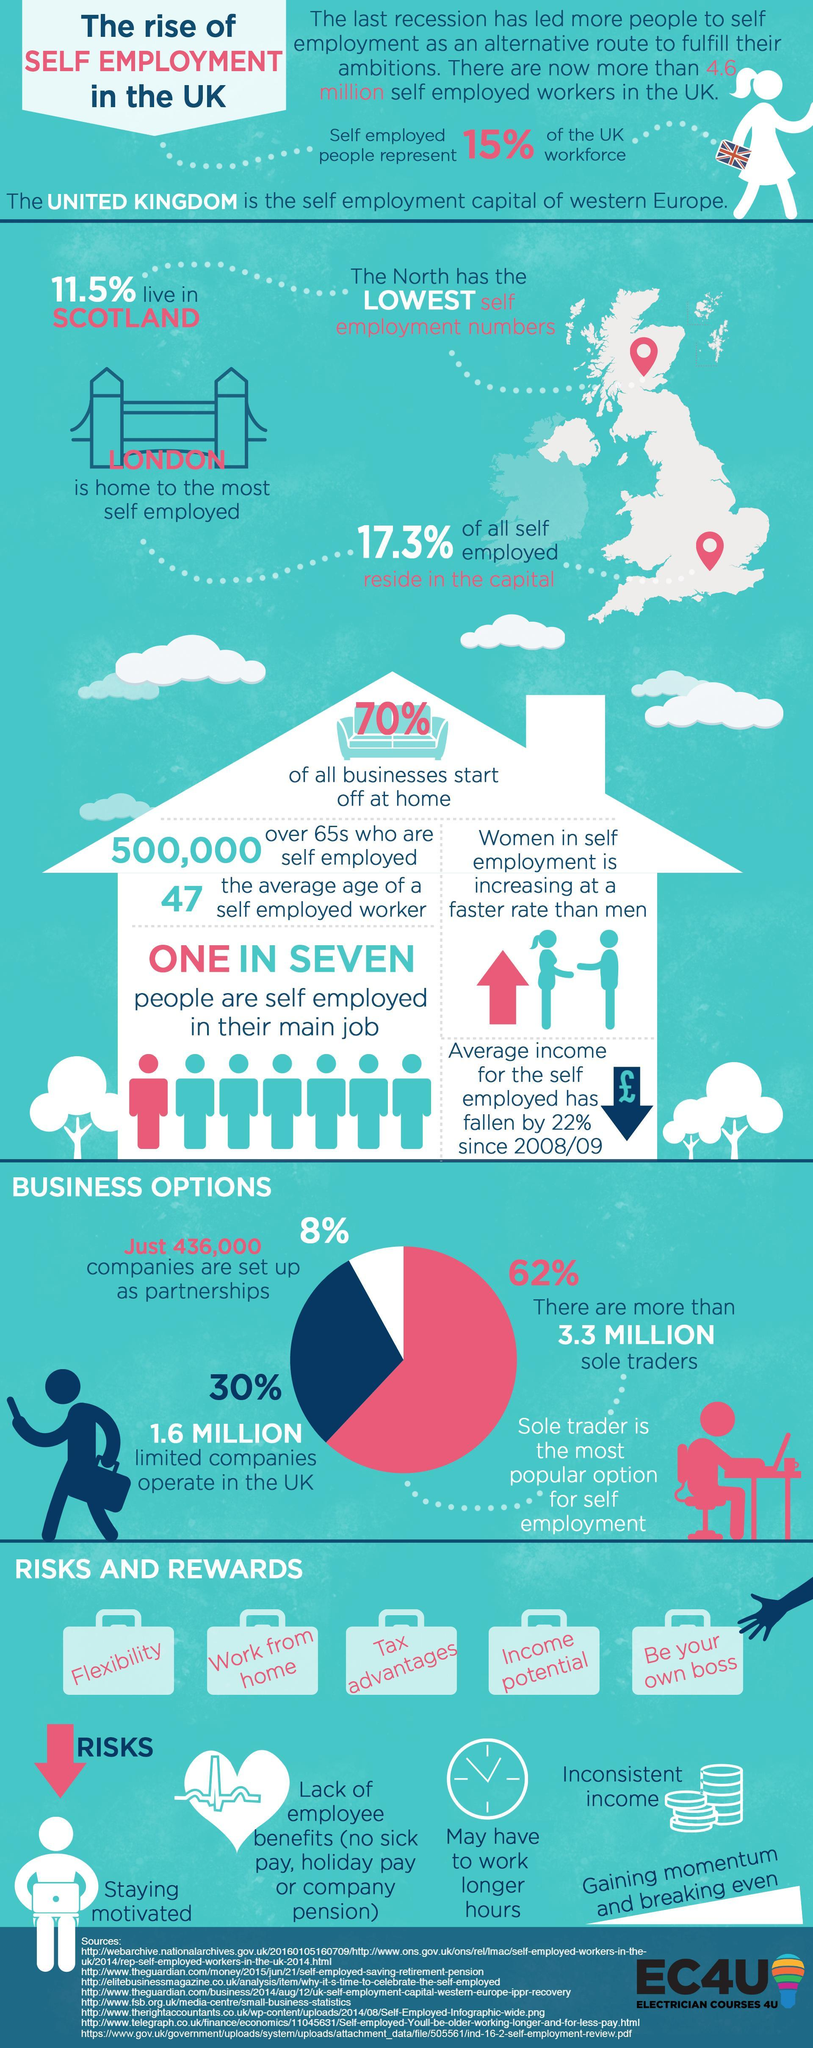Which are the three business options for the self employed?
Answer the question with a short phrase. partnerships, limited companies, sole traders How many risks are listed for the self employed? 5 Which most preferred method of self employment, partnerships, limited companies, or sole traders? sole traders Which color represents the companies set up as partnerships, blue, white, or red? white What is the difference in percentage of self employed people in London and Scotland? 5.8% How many rewards are listed for the self employed? 5 